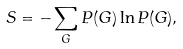<formula> <loc_0><loc_0><loc_500><loc_500>S = - \sum _ { G } P ( G ) \ln P ( G ) ,</formula> 